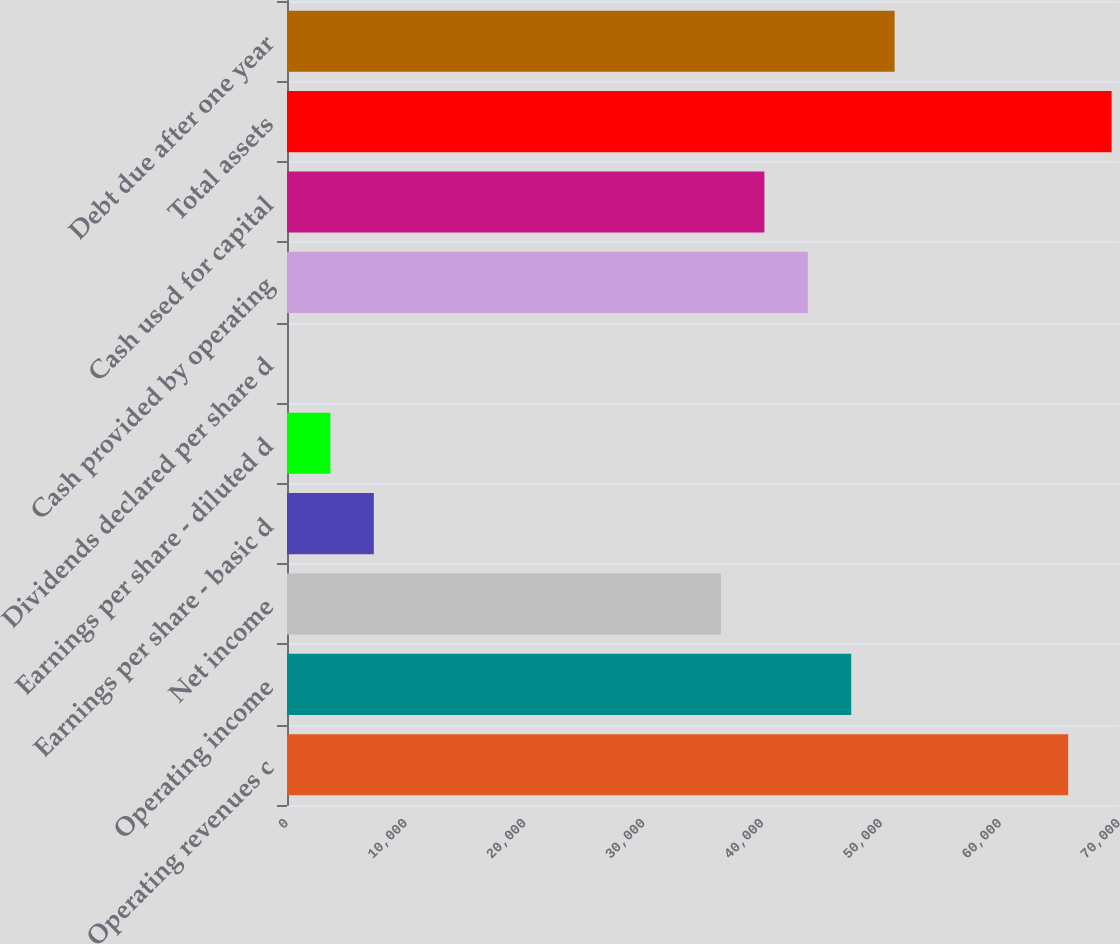<chart> <loc_0><loc_0><loc_500><loc_500><bar_chart><fcel>Operating revenues c<fcel>Operating income<fcel>Net income<fcel>Earnings per share - basic d<fcel>Earnings per share - diluted d<fcel>Dividends declared per share d<fcel>Cash provided by operating<fcel>Cash used for capital<fcel>Total assets<fcel>Debt due after one year<nl><fcel>65726.5<fcel>47469.3<fcel>36515<fcel>7303.48<fcel>3652.04<fcel>0.6<fcel>43817.9<fcel>40166.4<fcel>69378<fcel>51120.8<nl></chart> 